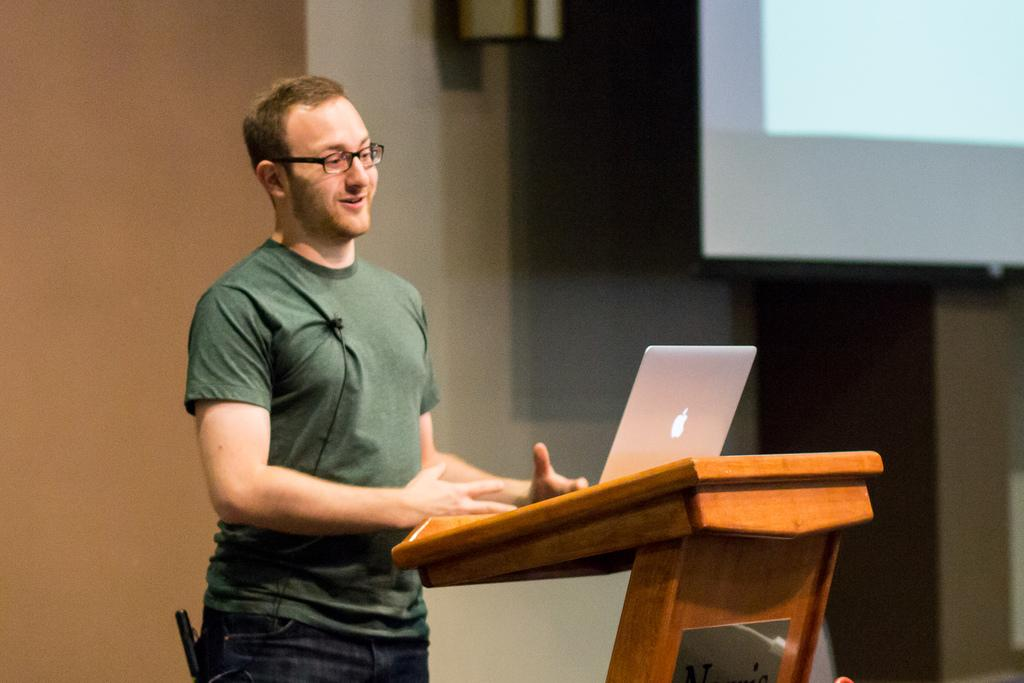What is the main subject of the image? There is a man in the image. What is the man doing in the image? The man is standing in the image. What object can be seen near the man? There is a laptop in the image, and it is on a podium. What is the man wearing in the image? The man is wearing a green t-shirt and spectacles. What type of pot is visible on the man's head in the image? There is no pot visible on the man's head in the image. What season is depicted in the image? The provided facts do not mention any seasonal details, so it cannot be determined from the image. 